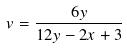Convert formula to latex. <formula><loc_0><loc_0><loc_500><loc_500>v = \frac { 6 y } { 1 2 y - 2 x + 3 }</formula> 